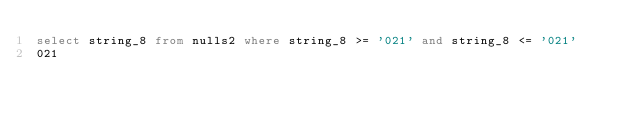Convert code to text. <code><loc_0><loc_0><loc_500><loc_500><_SQL_>select string_8 from nulls2 where string_8 >= '021' and string_8 <= '021'
021
</code> 